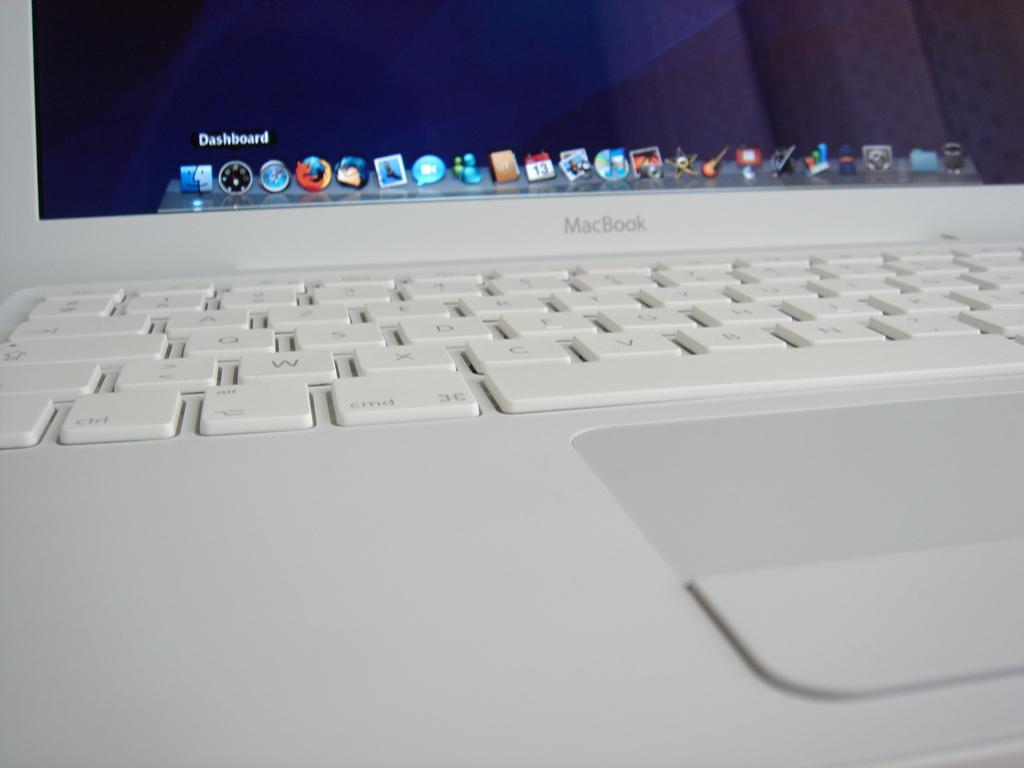<image>
Write a terse but informative summary of the picture. A white MacBook laptop is powered on and displays a list of icons in the bottom. 